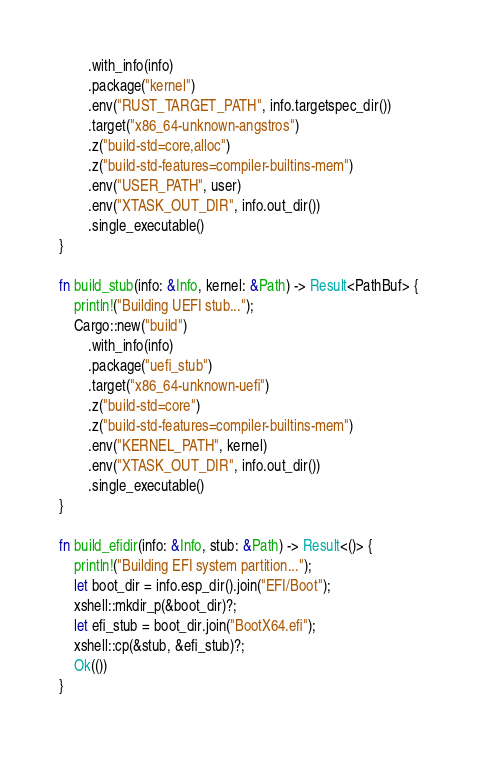<code> <loc_0><loc_0><loc_500><loc_500><_Rust_>        .with_info(info)
        .package("kernel")
        .env("RUST_TARGET_PATH", info.targetspec_dir())
        .target("x86_64-unknown-angstros")
        .z("build-std=core,alloc")
        .z("build-std-features=compiler-builtins-mem")
        .env("USER_PATH", user)
        .env("XTASK_OUT_DIR", info.out_dir())
        .single_executable()
}

fn build_stub(info: &Info, kernel: &Path) -> Result<PathBuf> {
    println!("Building UEFI stub...");
    Cargo::new("build")
        .with_info(info)
        .package("uefi_stub")
        .target("x86_64-unknown-uefi")
        .z("build-std=core")
        .z("build-std-features=compiler-builtins-mem")
        .env("KERNEL_PATH", kernel)
        .env("XTASK_OUT_DIR", info.out_dir())
        .single_executable()
}

fn build_efidir(info: &Info, stub: &Path) -> Result<()> {
    println!("Building EFI system partition...");
    let boot_dir = info.esp_dir().join("EFI/Boot");
    xshell::mkdir_p(&boot_dir)?;
    let efi_stub = boot_dir.join("BootX64.efi");
    xshell::cp(&stub, &efi_stub)?;
    Ok(())
}
</code> 